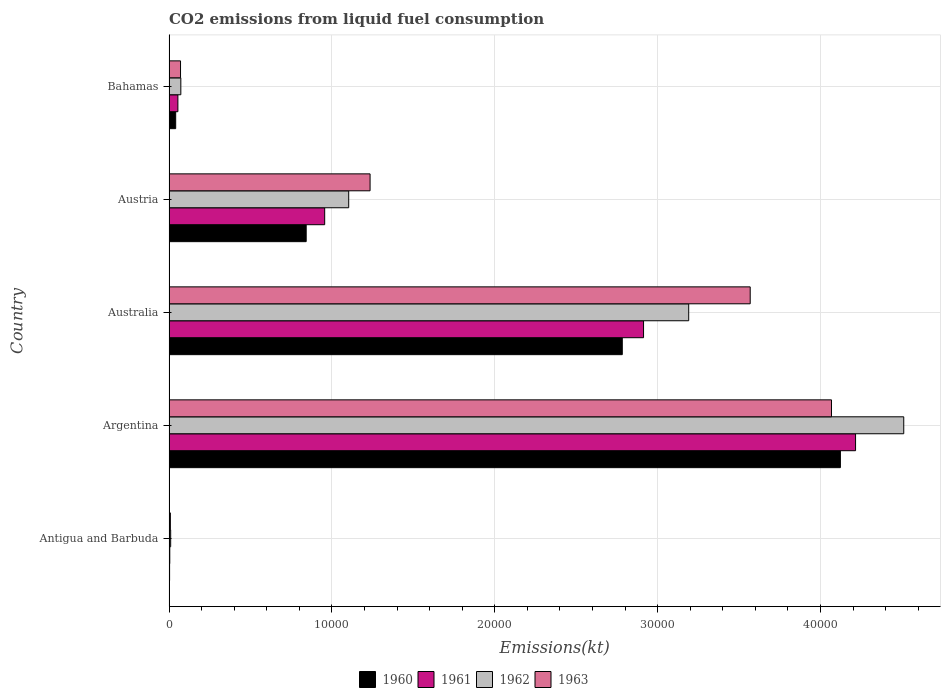How many groups of bars are there?
Offer a terse response. 5. How many bars are there on the 1st tick from the top?
Ensure brevity in your answer.  4. What is the label of the 1st group of bars from the top?
Offer a very short reply. Bahamas. In how many cases, is the number of bars for a given country not equal to the number of legend labels?
Keep it short and to the point. 0. What is the amount of CO2 emitted in 1962 in Bahamas?
Ensure brevity in your answer.  726.07. Across all countries, what is the maximum amount of CO2 emitted in 1961?
Your answer should be very brief. 4.22e+04. Across all countries, what is the minimum amount of CO2 emitted in 1961?
Your answer should be very brief. 47.67. In which country was the amount of CO2 emitted in 1962 minimum?
Make the answer very short. Antigua and Barbuda. What is the total amount of CO2 emitted in 1962 in the graph?
Your answer should be very brief. 8.89e+04. What is the difference between the amount of CO2 emitted in 1960 in Argentina and that in Austria?
Your response must be concise. 3.28e+04. What is the difference between the amount of CO2 emitted in 1962 in Austria and the amount of CO2 emitted in 1963 in Antigua and Barbuda?
Make the answer very short. 1.09e+04. What is the average amount of CO2 emitted in 1961 per country?
Your response must be concise. 1.63e+04. What is the difference between the amount of CO2 emitted in 1961 and amount of CO2 emitted in 1962 in Australia?
Keep it short and to the point. -2772.25. In how many countries, is the amount of CO2 emitted in 1961 greater than 14000 kt?
Offer a terse response. 2. What is the ratio of the amount of CO2 emitted in 1963 in Antigua and Barbuda to that in Bahamas?
Provide a short and direct response. 0.12. Is the amount of CO2 emitted in 1962 in Argentina less than that in Bahamas?
Provide a short and direct response. No. What is the difference between the highest and the second highest amount of CO2 emitted in 1961?
Keep it short and to the point. 1.30e+04. What is the difference between the highest and the lowest amount of CO2 emitted in 1962?
Provide a short and direct response. 4.50e+04. Is it the case that in every country, the sum of the amount of CO2 emitted in 1960 and amount of CO2 emitted in 1962 is greater than the sum of amount of CO2 emitted in 1961 and amount of CO2 emitted in 1963?
Your answer should be very brief. No. What does the 4th bar from the bottom in Antigua and Barbuda represents?
Provide a succinct answer. 1963. Are all the bars in the graph horizontal?
Ensure brevity in your answer.  Yes. What is the difference between two consecutive major ticks on the X-axis?
Offer a very short reply. 10000. Does the graph contain any zero values?
Offer a terse response. No. Where does the legend appear in the graph?
Your answer should be very brief. Bottom center. What is the title of the graph?
Your response must be concise. CO2 emissions from liquid fuel consumption. Does "1990" appear as one of the legend labels in the graph?
Your response must be concise. No. What is the label or title of the X-axis?
Provide a succinct answer. Emissions(kt). What is the Emissions(kt) of 1960 in Antigua and Barbuda?
Provide a succinct answer. 36.67. What is the Emissions(kt) in 1961 in Antigua and Barbuda?
Provide a succinct answer. 47.67. What is the Emissions(kt) in 1962 in Antigua and Barbuda?
Ensure brevity in your answer.  102.68. What is the Emissions(kt) in 1963 in Antigua and Barbuda?
Keep it short and to the point. 84.34. What is the Emissions(kt) of 1960 in Argentina?
Offer a terse response. 4.12e+04. What is the Emissions(kt) in 1961 in Argentina?
Keep it short and to the point. 4.22e+04. What is the Emissions(kt) of 1962 in Argentina?
Your response must be concise. 4.51e+04. What is the Emissions(kt) of 1963 in Argentina?
Give a very brief answer. 4.07e+04. What is the Emissions(kt) of 1960 in Australia?
Make the answer very short. 2.78e+04. What is the Emissions(kt) of 1961 in Australia?
Your answer should be very brief. 2.91e+04. What is the Emissions(kt) in 1962 in Australia?
Your answer should be compact. 3.19e+04. What is the Emissions(kt) of 1963 in Australia?
Make the answer very short. 3.57e+04. What is the Emissions(kt) in 1960 in Austria?
Offer a terse response. 8423.1. What is the Emissions(kt) in 1961 in Austria?
Your response must be concise. 9559.87. What is the Emissions(kt) of 1962 in Austria?
Keep it short and to the point. 1.10e+04. What is the Emissions(kt) in 1963 in Austria?
Offer a very short reply. 1.23e+04. What is the Emissions(kt) in 1960 in Bahamas?
Keep it short and to the point. 410.7. What is the Emissions(kt) of 1961 in Bahamas?
Provide a short and direct response. 546.38. What is the Emissions(kt) in 1962 in Bahamas?
Provide a succinct answer. 726.07. What is the Emissions(kt) in 1963 in Bahamas?
Offer a terse response. 707.73. Across all countries, what is the maximum Emissions(kt) of 1960?
Offer a very short reply. 4.12e+04. Across all countries, what is the maximum Emissions(kt) in 1961?
Make the answer very short. 4.22e+04. Across all countries, what is the maximum Emissions(kt) of 1962?
Provide a succinct answer. 4.51e+04. Across all countries, what is the maximum Emissions(kt) in 1963?
Your response must be concise. 4.07e+04. Across all countries, what is the minimum Emissions(kt) in 1960?
Give a very brief answer. 36.67. Across all countries, what is the minimum Emissions(kt) in 1961?
Your answer should be very brief. 47.67. Across all countries, what is the minimum Emissions(kt) of 1962?
Make the answer very short. 102.68. Across all countries, what is the minimum Emissions(kt) of 1963?
Provide a succinct answer. 84.34. What is the total Emissions(kt) of 1960 in the graph?
Ensure brevity in your answer.  7.79e+04. What is the total Emissions(kt) in 1961 in the graph?
Your response must be concise. 8.14e+04. What is the total Emissions(kt) in 1962 in the graph?
Offer a very short reply. 8.89e+04. What is the total Emissions(kt) of 1963 in the graph?
Your response must be concise. 8.95e+04. What is the difference between the Emissions(kt) of 1960 in Antigua and Barbuda and that in Argentina?
Ensure brevity in your answer.  -4.12e+04. What is the difference between the Emissions(kt) in 1961 in Antigua and Barbuda and that in Argentina?
Give a very brief answer. -4.21e+04. What is the difference between the Emissions(kt) of 1962 in Antigua and Barbuda and that in Argentina?
Your answer should be very brief. -4.50e+04. What is the difference between the Emissions(kt) in 1963 in Antigua and Barbuda and that in Argentina?
Provide a succinct answer. -4.06e+04. What is the difference between the Emissions(kt) in 1960 in Antigua and Barbuda and that in Australia?
Keep it short and to the point. -2.78e+04. What is the difference between the Emissions(kt) of 1961 in Antigua and Barbuda and that in Australia?
Your response must be concise. -2.91e+04. What is the difference between the Emissions(kt) in 1962 in Antigua and Barbuda and that in Australia?
Ensure brevity in your answer.  -3.18e+04. What is the difference between the Emissions(kt) in 1963 in Antigua and Barbuda and that in Australia?
Give a very brief answer. -3.56e+04. What is the difference between the Emissions(kt) in 1960 in Antigua and Barbuda and that in Austria?
Give a very brief answer. -8386.43. What is the difference between the Emissions(kt) of 1961 in Antigua and Barbuda and that in Austria?
Give a very brief answer. -9512.2. What is the difference between the Emissions(kt) of 1962 in Antigua and Barbuda and that in Austria?
Your response must be concise. -1.09e+04. What is the difference between the Emissions(kt) of 1963 in Antigua and Barbuda and that in Austria?
Keep it short and to the point. -1.23e+04. What is the difference between the Emissions(kt) in 1960 in Antigua and Barbuda and that in Bahamas?
Keep it short and to the point. -374.03. What is the difference between the Emissions(kt) in 1961 in Antigua and Barbuda and that in Bahamas?
Offer a very short reply. -498.71. What is the difference between the Emissions(kt) in 1962 in Antigua and Barbuda and that in Bahamas?
Provide a short and direct response. -623.39. What is the difference between the Emissions(kt) in 1963 in Antigua and Barbuda and that in Bahamas?
Your answer should be very brief. -623.39. What is the difference between the Emissions(kt) in 1960 in Argentina and that in Australia?
Your answer should be compact. 1.34e+04. What is the difference between the Emissions(kt) in 1961 in Argentina and that in Australia?
Provide a short and direct response. 1.30e+04. What is the difference between the Emissions(kt) of 1962 in Argentina and that in Australia?
Your answer should be very brief. 1.32e+04. What is the difference between the Emissions(kt) of 1963 in Argentina and that in Australia?
Make the answer very short. 4990.79. What is the difference between the Emissions(kt) in 1960 in Argentina and that in Austria?
Offer a terse response. 3.28e+04. What is the difference between the Emissions(kt) in 1961 in Argentina and that in Austria?
Your answer should be compact. 3.26e+04. What is the difference between the Emissions(kt) in 1962 in Argentina and that in Austria?
Give a very brief answer. 3.41e+04. What is the difference between the Emissions(kt) in 1963 in Argentina and that in Austria?
Keep it short and to the point. 2.83e+04. What is the difference between the Emissions(kt) of 1960 in Argentina and that in Bahamas?
Your answer should be very brief. 4.08e+04. What is the difference between the Emissions(kt) in 1961 in Argentina and that in Bahamas?
Offer a terse response. 4.16e+04. What is the difference between the Emissions(kt) in 1962 in Argentina and that in Bahamas?
Make the answer very short. 4.44e+04. What is the difference between the Emissions(kt) in 1963 in Argentina and that in Bahamas?
Provide a succinct answer. 4.00e+04. What is the difference between the Emissions(kt) in 1960 in Australia and that in Austria?
Give a very brief answer. 1.94e+04. What is the difference between the Emissions(kt) in 1961 in Australia and that in Austria?
Your answer should be compact. 1.96e+04. What is the difference between the Emissions(kt) of 1962 in Australia and that in Austria?
Ensure brevity in your answer.  2.09e+04. What is the difference between the Emissions(kt) in 1963 in Australia and that in Austria?
Provide a short and direct response. 2.33e+04. What is the difference between the Emissions(kt) in 1960 in Australia and that in Bahamas?
Your response must be concise. 2.74e+04. What is the difference between the Emissions(kt) of 1961 in Australia and that in Bahamas?
Offer a terse response. 2.86e+04. What is the difference between the Emissions(kt) in 1962 in Australia and that in Bahamas?
Ensure brevity in your answer.  3.12e+04. What is the difference between the Emissions(kt) in 1963 in Australia and that in Bahamas?
Keep it short and to the point. 3.50e+04. What is the difference between the Emissions(kt) of 1960 in Austria and that in Bahamas?
Your answer should be compact. 8012.4. What is the difference between the Emissions(kt) of 1961 in Austria and that in Bahamas?
Your answer should be compact. 9013.49. What is the difference between the Emissions(kt) of 1962 in Austria and that in Bahamas?
Your answer should be compact. 1.03e+04. What is the difference between the Emissions(kt) in 1963 in Austria and that in Bahamas?
Your answer should be compact. 1.16e+04. What is the difference between the Emissions(kt) in 1960 in Antigua and Barbuda and the Emissions(kt) in 1961 in Argentina?
Give a very brief answer. -4.21e+04. What is the difference between the Emissions(kt) of 1960 in Antigua and Barbuda and the Emissions(kt) of 1962 in Argentina?
Your answer should be very brief. -4.51e+04. What is the difference between the Emissions(kt) of 1960 in Antigua and Barbuda and the Emissions(kt) of 1963 in Argentina?
Your answer should be compact. -4.06e+04. What is the difference between the Emissions(kt) of 1961 in Antigua and Barbuda and the Emissions(kt) of 1962 in Argentina?
Your answer should be compact. -4.51e+04. What is the difference between the Emissions(kt) of 1961 in Antigua and Barbuda and the Emissions(kt) of 1963 in Argentina?
Your response must be concise. -4.06e+04. What is the difference between the Emissions(kt) of 1962 in Antigua and Barbuda and the Emissions(kt) of 1963 in Argentina?
Offer a very short reply. -4.06e+04. What is the difference between the Emissions(kt) of 1960 in Antigua and Barbuda and the Emissions(kt) of 1961 in Australia?
Keep it short and to the point. -2.91e+04. What is the difference between the Emissions(kt) of 1960 in Antigua and Barbuda and the Emissions(kt) of 1962 in Australia?
Make the answer very short. -3.19e+04. What is the difference between the Emissions(kt) in 1960 in Antigua and Barbuda and the Emissions(kt) in 1963 in Australia?
Offer a terse response. -3.57e+04. What is the difference between the Emissions(kt) in 1961 in Antigua and Barbuda and the Emissions(kt) in 1962 in Australia?
Offer a terse response. -3.19e+04. What is the difference between the Emissions(kt) of 1961 in Antigua and Barbuda and the Emissions(kt) of 1963 in Australia?
Provide a succinct answer. -3.56e+04. What is the difference between the Emissions(kt) of 1962 in Antigua and Barbuda and the Emissions(kt) of 1963 in Australia?
Make the answer very short. -3.56e+04. What is the difference between the Emissions(kt) in 1960 in Antigua and Barbuda and the Emissions(kt) in 1961 in Austria?
Keep it short and to the point. -9523.2. What is the difference between the Emissions(kt) of 1960 in Antigua and Barbuda and the Emissions(kt) of 1962 in Austria?
Your answer should be very brief. -1.10e+04. What is the difference between the Emissions(kt) in 1960 in Antigua and Barbuda and the Emissions(kt) in 1963 in Austria?
Make the answer very short. -1.23e+04. What is the difference between the Emissions(kt) of 1961 in Antigua and Barbuda and the Emissions(kt) of 1962 in Austria?
Your answer should be compact. -1.10e+04. What is the difference between the Emissions(kt) of 1961 in Antigua and Barbuda and the Emissions(kt) of 1963 in Austria?
Ensure brevity in your answer.  -1.23e+04. What is the difference between the Emissions(kt) of 1962 in Antigua and Barbuda and the Emissions(kt) of 1963 in Austria?
Your answer should be very brief. -1.22e+04. What is the difference between the Emissions(kt) of 1960 in Antigua and Barbuda and the Emissions(kt) of 1961 in Bahamas?
Ensure brevity in your answer.  -509.71. What is the difference between the Emissions(kt) in 1960 in Antigua and Barbuda and the Emissions(kt) in 1962 in Bahamas?
Your answer should be compact. -689.4. What is the difference between the Emissions(kt) in 1960 in Antigua and Barbuda and the Emissions(kt) in 1963 in Bahamas?
Provide a succinct answer. -671.06. What is the difference between the Emissions(kt) in 1961 in Antigua and Barbuda and the Emissions(kt) in 1962 in Bahamas?
Make the answer very short. -678.39. What is the difference between the Emissions(kt) in 1961 in Antigua and Barbuda and the Emissions(kt) in 1963 in Bahamas?
Offer a terse response. -660.06. What is the difference between the Emissions(kt) of 1962 in Antigua and Barbuda and the Emissions(kt) of 1963 in Bahamas?
Offer a very short reply. -605.05. What is the difference between the Emissions(kt) of 1960 in Argentina and the Emissions(kt) of 1961 in Australia?
Your response must be concise. 1.21e+04. What is the difference between the Emissions(kt) in 1960 in Argentina and the Emissions(kt) in 1962 in Australia?
Your answer should be very brief. 9314.18. What is the difference between the Emissions(kt) of 1960 in Argentina and the Emissions(kt) of 1963 in Australia?
Offer a very short reply. 5537.17. What is the difference between the Emissions(kt) of 1961 in Argentina and the Emissions(kt) of 1962 in Australia?
Offer a terse response. 1.02e+04. What is the difference between the Emissions(kt) of 1961 in Argentina and the Emissions(kt) of 1963 in Australia?
Your answer should be very brief. 6468.59. What is the difference between the Emissions(kt) in 1962 in Argentina and the Emissions(kt) in 1963 in Australia?
Provide a short and direct response. 9427.86. What is the difference between the Emissions(kt) of 1960 in Argentina and the Emissions(kt) of 1961 in Austria?
Keep it short and to the point. 3.17e+04. What is the difference between the Emissions(kt) in 1960 in Argentina and the Emissions(kt) in 1962 in Austria?
Ensure brevity in your answer.  3.02e+04. What is the difference between the Emissions(kt) in 1960 in Argentina and the Emissions(kt) in 1963 in Austria?
Your answer should be very brief. 2.89e+04. What is the difference between the Emissions(kt) of 1961 in Argentina and the Emissions(kt) of 1962 in Austria?
Your response must be concise. 3.11e+04. What is the difference between the Emissions(kt) in 1961 in Argentina and the Emissions(kt) in 1963 in Austria?
Offer a very short reply. 2.98e+04. What is the difference between the Emissions(kt) in 1962 in Argentina and the Emissions(kt) in 1963 in Austria?
Provide a short and direct response. 3.28e+04. What is the difference between the Emissions(kt) in 1960 in Argentina and the Emissions(kt) in 1961 in Bahamas?
Offer a very short reply. 4.07e+04. What is the difference between the Emissions(kt) of 1960 in Argentina and the Emissions(kt) of 1962 in Bahamas?
Ensure brevity in your answer.  4.05e+04. What is the difference between the Emissions(kt) of 1960 in Argentina and the Emissions(kt) of 1963 in Bahamas?
Offer a terse response. 4.05e+04. What is the difference between the Emissions(kt) of 1961 in Argentina and the Emissions(kt) of 1962 in Bahamas?
Your response must be concise. 4.14e+04. What is the difference between the Emissions(kt) in 1961 in Argentina and the Emissions(kt) in 1963 in Bahamas?
Give a very brief answer. 4.14e+04. What is the difference between the Emissions(kt) in 1962 in Argentina and the Emissions(kt) in 1963 in Bahamas?
Your answer should be compact. 4.44e+04. What is the difference between the Emissions(kt) in 1960 in Australia and the Emissions(kt) in 1961 in Austria?
Your response must be concise. 1.83e+04. What is the difference between the Emissions(kt) in 1960 in Australia and the Emissions(kt) in 1962 in Austria?
Offer a terse response. 1.68e+04. What is the difference between the Emissions(kt) of 1960 in Australia and the Emissions(kt) of 1963 in Austria?
Ensure brevity in your answer.  1.55e+04. What is the difference between the Emissions(kt) of 1961 in Australia and the Emissions(kt) of 1962 in Austria?
Provide a short and direct response. 1.81e+04. What is the difference between the Emissions(kt) in 1961 in Australia and the Emissions(kt) in 1963 in Austria?
Provide a succinct answer. 1.68e+04. What is the difference between the Emissions(kt) of 1962 in Australia and the Emissions(kt) of 1963 in Austria?
Your answer should be very brief. 1.96e+04. What is the difference between the Emissions(kt) of 1960 in Australia and the Emissions(kt) of 1961 in Bahamas?
Offer a very short reply. 2.73e+04. What is the difference between the Emissions(kt) in 1960 in Australia and the Emissions(kt) in 1962 in Bahamas?
Ensure brevity in your answer.  2.71e+04. What is the difference between the Emissions(kt) of 1960 in Australia and the Emissions(kt) of 1963 in Bahamas?
Provide a succinct answer. 2.71e+04. What is the difference between the Emissions(kt) of 1961 in Australia and the Emissions(kt) of 1962 in Bahamas?
Keep it short and to the point. 2.84e+04. What is the difference between the Emissions(kt) in 1961 in Australia and the Emissions(kt) in 1963 in Bahamas?
Give a very brief answer. 2.84e+04. What is the difference between the Emissions(kt) in 1962 in Australia and the Emissions(kt) in 1963 in Bahamas?
Offer a very short reply. 3.12e+04. What is the difference between the Emissions(kt) of 1960 in Austria and the Emissions(kt) of 1961 in Bahamas?
Your answer should be very brief. 7876.72. What is the difference between the Emissions(kt) of 1960 in Austria and the Emissions(kt) of 1962 in Bahamas?
Provide a short and direct response. 7697.03. What is the difference between the Emissions(kt) in 1960 in Austria and the Emissions(kt) in 1963 in Bahamas?
Give a very brief answer. 7715.37. What is the difference between the Emissions(kt) of 1961 in Austria and the Emissions(kt) of 1962 in Bahamas?
Make the answer very short. 8833.8. What is the difference between the Emissions(kt) in 1961 in Austria and the Emissions(kt) in 1963 in Bahamas?
Keep it short and to the point. 8852.14. What is the difference between the Emissions(kt) in 1962 in Austria and the Emissions(kt) in 1963 in Bahamas?
Your answer should be compact. 1.03e+04. What is the average Emissions(kt) of 1960 per country?
Give a very brief answer. 1.56e+04. What is the average Emissions(kt) in 1961 per country?
Ensure brevity in your answer.  1.63e+04. What is the average Emissions(kt) in 1962 per country?
Offer a very short reply. 1.78e+04. What is the average Emissions(kt) in 1963 per country?
Provide a short and direct response. 1.79e+04. What is the difference between the Emissions(kt) in 1960 and Emissions(kt) in 1961 in Antigua and Barbuda?
Keep it short and to the point. -11. What is the difference between the Emissions(kt) in 1960 and Emissions(kt) in 1962 in Antigua and Barbuda?
Provide a short and direct response. -66.01. What is the difference between the Emissions(kt) in 1960 and Emissions(kt) in 1963 in Antigua and Barbuda?
Provide a succinct answer. -47.67. What is the difference between the Emissions(kt) of 1961 and Emissions(kt) of 1962 in Antigua and Barbuda?
Your answer should be compact. -55.01. What is the difference between the Emissions(kt) of 1961 and Emissions(kt) of 1963 in Antigua and Barbuda?
Keep it short and to the point. -36.67. What is the difference between the Emissions(kt) of 1962 and Emissions(kt) of 1963 in Antigua and Barbuda?
Offer a very short reply. 18.34. What is the difference between the Emissions(kt) in 1960 and Emissions(kt) in 1961 in Argentina?
Offer a terse response. -931.42. What is the difference between the Emissions(kt) of 1960 and Emissions(kt) of 1962 in Argentina?
Give a very brief answer. -3890.69. What is the difference between the Emissions(kt) of 1960 and Emissions(kt) of 1963 in Argentina?
Your answer should be compact. 546.38. What is the difference between the Emissions(kt) of 1961 and Emissions(kt) of 1962 in Argentina?
Your answer should be very brief. -2959.27. What is the difference between the Emissions(kt) in 1961 and Emissions(kt) in 1963 in Argentina?
Offer a terse response. 1477.8. What is the difference between the Emissions(kt) of 1962 and Emissions(kt) of 1963 in Argentina?
Your answer should be very brief. 4437.07. What is the difference between the Emissions(kt) in 1960 and Emissions(kt) in 1961 in Australia?
Provide a succinct answer. -1305.45. What is the difference between the Emissions(kt) of 1960 and Emissions(kt) of 1962 in Australia?
Provide a short and direct response. -4077.7. What is the difference between the Emissions(kt) of 1960 and Emissions(kt) of 1963 in Australia?
Your answer should be compact. -7854.71. What is the difference between the Emissions(kt) of 1961 and Emissions(kt) of 1962 in Australia?
Your answer should be compact. -2772.25. What is the difference between the Emissions(kt) of 1961 and Emissions(kt) of 1963 in Australia?
Offer a terse response. -6549.26. What is the difference between the Emissions(kt) of 1962 and Emissions(kt) of 1963 in Australia?
Ensure brevity in your answer.  -3777.01. What is the difference between the Emissions(kt) in 1960 and Emissions(kt) in 1961 in Austria?
Your answer should be compact. -1136.77. What is the difference between the Emissions(kt) in 1960 and Emissions(kt) in 1962 in Austria?
Ensure brevity in your answer.  -2610.9. What is the difference between the Emissions(kt) of 1960 and Emissions(kt) of 1963 in Austria?
Provide a succinct answer. -3923.69. What is the difference between the Emissions(kt) in 1961 and Emissions(kt) in 1962 in Austria?
Your response must be concise. -1474.13. What is the difference between the Emissions(kt) in 1961 and Emissions(kt) in 1963 in Austria?
Your answer should be very brief. -2786.92. What is the difference between the Emissions(kt) of 1962 and Emissions(kt) of 1963 in Austria?
Your answer should be compact. -1312.79. What is the difference between the Emissions(kt) in 1960 and Emissions(kt) in 1961 in Bahamas?
Provide a short and direct response. -135.68. What is the difference between the Emissions(kt) in 1960 and Emissions(kt) in 1962 in Bahamas?
Provide a short and direct response. -315.36. What is the difference between the Emissions(kt) in 1960 and Emissions(kt) in 1963 in Bahamas?
Offer a very short reply. -297.03. What is the difference between the Emissions(kt) in 1961 and Emissions(kt) in 1962 in Bahamas?
Your answer should be very brief. -179.68. What is the difference between the Emissions(kt) in 1961 and Emissions(kt) in 1963 in Bahamas?
Offer a terse response. -161.35. What is the difference between the Emissions(kt) of 1962 and Emissions(kt) of 1963 in Bahamas?
Make the answer very short. 18.34. What is the ratio of the Emissions(kt) in 1960 in Antigua and Barbuda to that in Argentina?
Offer a very short reply. 0. What is the ratio of the Emissions(kt) in 1961 in Antigua and Barbuda to that in Argentina?
Keep it short and to the point. 0. What is the ratio of the Emissions(kt) of 1962 in Antigua and Barbuda to that in Argentina?
Offer a very short reply. 0. What is the ratio of the Emissions(kt) in 1963 in Antigua and Barbuda to that in Argentina?
Provide a short and direct response. 0. What is the ratio of the Emissions(kt) in 1960 in Antigua and Barbuda to that in Australia?
Ensure brevity in your answer.  0. What is the ratio of the Emissions(kt) of 1961 in Antigua and Barbuda to that in Australia?
Provide a succinct answer. 0. What is the ratio of the Emissions(kt) of 1962 in Antigua and Barbuda to that in Australia?
Your answer should be very brief. 0. What is the ratio of the Emissions(kt) of 1963 in Antigua and Barbuda to that in Australia?
Your answer should be very brief. 0. What is the ratio of the Emissions(kt) in 1960 in Antigua and Barbuda to that in Austria?
Keep it short and to the point. 0. What is the ratio of the Emissions(kt) in 1961 in Antigua and Barbuda to that in Austria?
Give a very brief answer. 0.01. What is the ratio of the Emissions(kt) in 1962 in Antigua and Barbuda to that in Austria?
Your answer should be compact. 0.01. What is the ratio of the Emissions(kt) of 1963 in Antigua and Barbuda to that in Austria?
Offer a terse response. 0.01. What is the ratio of the Emissions(kt) in 1960 in Antigua and Barbuda to that in Bahamas?
Make the answer very short. 0.09. What is the ratio of the Emissions(kt) of 1961 in Antigua and Barbuda to that in Bahamas?
Your answer should be very brief. 0.09. What is the ratio of the Emissions(kt) of 1962 in Antigua and Barbuda to that in Bahamas?
Give a very brief answer. 0.14. What is the ratio of the Emissions(kt) of 1963 in Antigua and Barbuda to that in Bahamas?
Offer a very short reply. 0.12. What is the ratio of the Emissions(kt) of 1960 in Argentina to that in Australia?
Ensure brevity in your answer.  1.48. What is the ratio of the Emissions(kt) in 1961 in Argentina to that in Australia?
Your response must be concise. 1.45. What is the ratio of the Emissions(kt) in 1962 in Argentina to that in Australia?
Your response must be concise. 1.41. What is the ratio of the Emissions(kt) in 1963 in Argentina to that in Australia?
Give a very brief answer. 1.14. What is the ratio of the Emissions(kt) in 1960 in Argentina to that in Austria?
Give a very brief answer. 4.89. What is the ratio of the Emissions(kt) of 1961 in Argentina to that in Austria?
Your answer should be very brief. 4.41. What is the ratio of the Emissions(kt) of 1962 in Argentina to that in Austria?
Provide a succinct answer. 4.09. What is the ratio of the Emissions(kt) of 1963 in Argentina to that in Austria?
Make the answer very short. 3.29. What is the ratio of the Emissions(kt) of 1960 in Argentina to that in Bahamas?
Keep it short and to the point. 100.38. What is the ratio of the Emissions(kt) of 1961 in Argentina to that in Bahamas?
Make the answer very short. 77.15. What is the ratio of the Emissions(kt) in 1962 in Argentina to that in Bahamas?
Provide a short and direct response. 62.14. What is the ratio of the Emissions(kt) of 1963 in Argentina to that in Bahamas?
Your answer should be compact. 57.48. What is the ratio of the Emissions(kt) of 1960 in Australia to that in Austria?
Your answer should be compact. 3.3. What is the ratio of the Emissions(kt) of 1961 in Australia to that in Austria?
Your answer should be compact. 3.05. What is the ratio of the Emissions(kt) in 1962 in Australia to that in Austria?
Provide a short and direct response. 2.89. What is the ratio of the Emissions(kt) in 1963 in Australia to that in Austria?
Provide a short and direct response. 2.89. What is the ratio of the Emissions(kt) in 1960 in Australia to that in Bahamas?
Provide a succinct answer. 67.77. What is the ratio of the Emissions(kt) in 1961 in Australia to that in Bahamas?
Offer a very short reply. 53.33. What is the ratio of the Emissions(kt) of 1962 in Australia to that in Bahamas?
Ensure brevity in your answer.  43.95. What is the ratio of the Emissions(kt) in 1963 in Australia to that in Bahamas?
Provide a short and direct response. 50.42. What is the ratio of the Emissions(kt) in 1960 in Austria to that in Bahamas?
Offer a terse response. 20.51. What is the ratio of the Emissions(kt) of 1961 in Austria to that in Bahamas?
Provide a succinct answer. 17.5. What is the ratio of the Emissions(kt) in 1962 in Austria to that in Bahamas?
Offer a terse response. 15.2. What is the ratio of the Emissions(kt) of 1963 in Austria to that in Bahamas?
Make the answer very short. 17.45. What is the difference between the highest and the second highest Emissions(kt) in 1960?
Provide a succinct answer. 1.34e+04. What is the difference between the highest and the second highest Emissions(kt) in 1961?
Keep it short and to the point. 1.30e+04. What is the difference between the highest and the second highest Emissions(kt) of 1962?
Provide a succinct answer. 1.32e+04. What is the difference between the highest and the second highest Emissions(kt) in 1963?
Your answer should be very brief. 4990.79. What is the difference between the highest and the lowest Emissions(kt) in 1960?
Ensure brevity in your answer.  4.12e+04. What is the difference between the highest and the lowest Emissions(kt) in 1961?
Give a very brief answer. 4.21e+04. What is the difference between the highest and the lowest Emissions(kt) in 1962?
Your answer should be compact. 4.50e+04. What is the difference between the highest and the lowest Emissions(kt) in 1963?
Provide a short and direct response. 4.06e+04. 